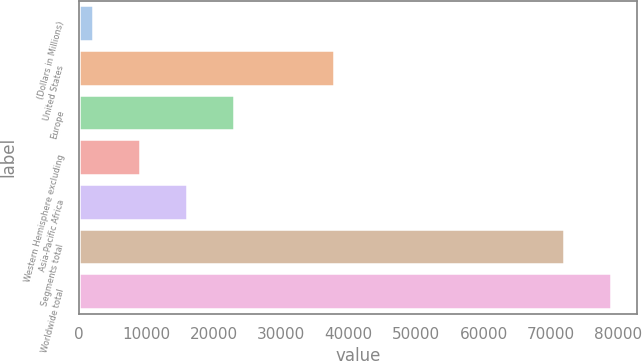Convert chart. <chart><loc_0><loc_0><loc_500><loc_500><bar_chart><fcel>(Dollars in Millions)<fcel>United States<fcel>Europe<fcel>Western Hemisphere excluding<fcel>Asia-Pacific Africa<fcel>Segments total<fcel>Worldwide total<nl><fcel>2016<fcel>37811<fcel>22978.2<fcel>9003.4<fcel>15990.8<fcel>71890<fcel>78877.4<nl></chart> 